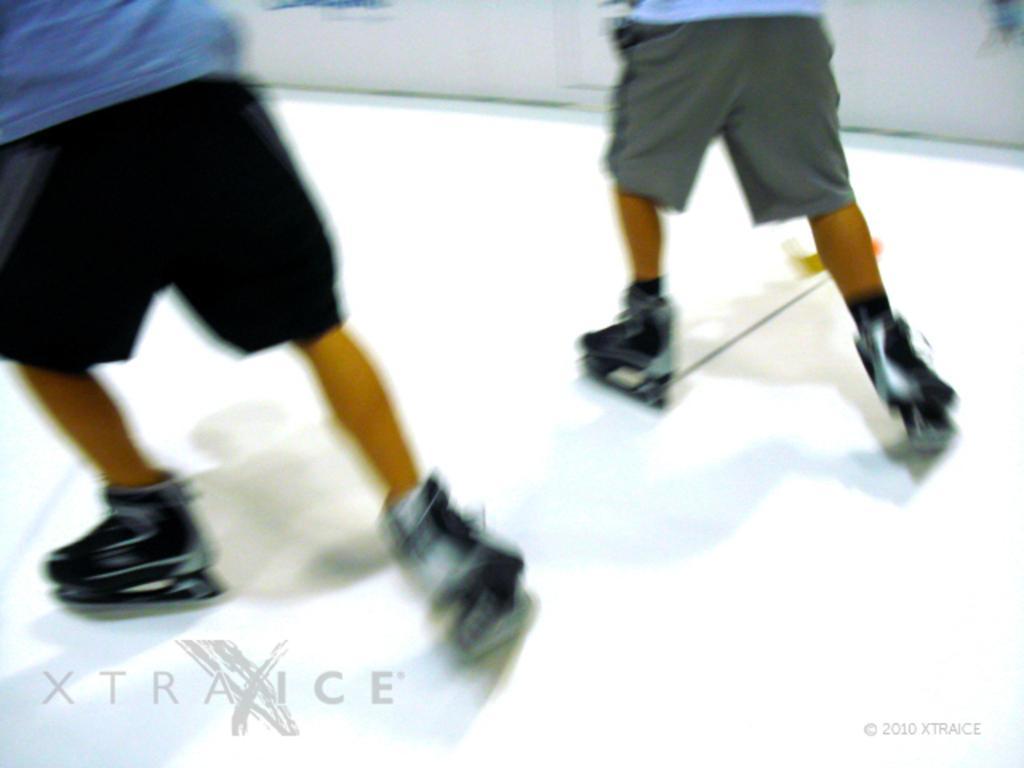In one or two sentences, can you explain what this image depicts? In the image we can see there are two people wearing roller skates and standing on the ground. 